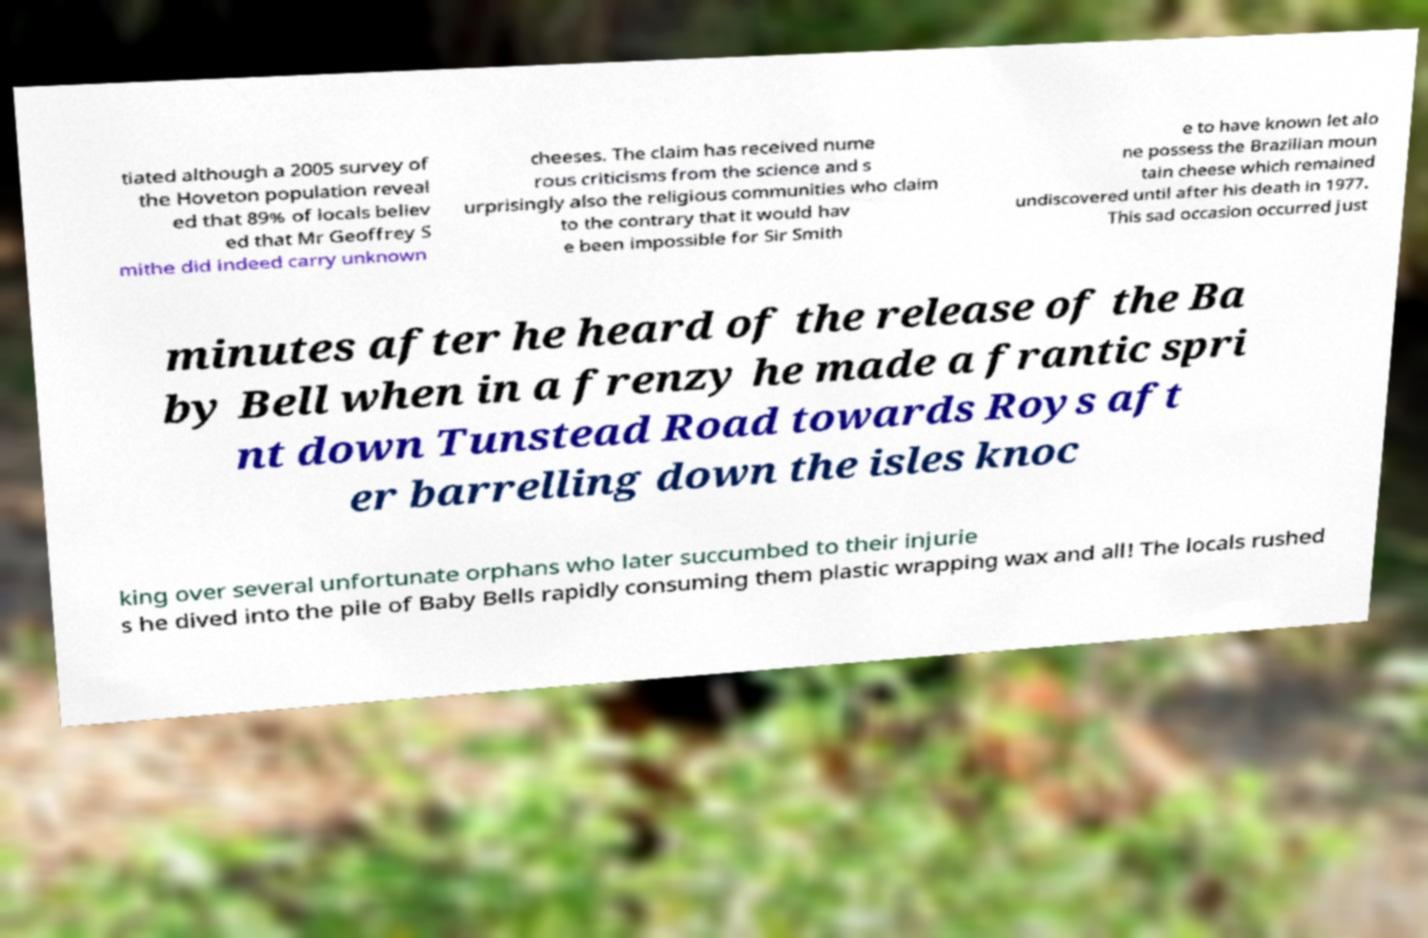Please read and relay the text visible in this image. What does it say? tiated although a 2005 survey of the Hoveton population reveal ed that 89% of locals believ ed that Mr Geoffrey S mithe did indeed carry unknown cheeses. The claim has received nume rous criticisms from the science and s urprisingly also the religious communities who claim to the contrary that it would hav e been impossible for Sir Smith e to have known let alo ne possess the Brazilian moun tain cheese which remained undiscovered until after his death in 1977. This sad occasion occurred just minutes after he heard of the release of the Ba by Bell when in a frenzy he made a frantic spri nt down Tunstead Road towards Roys aft er barrelling down the isles knoc king over several unfortunate orphans who later succumbed to their injurie s he dived into the pile of Baby Bells rapidly consuming them plastic wrapping wax and all! The locals rushed 